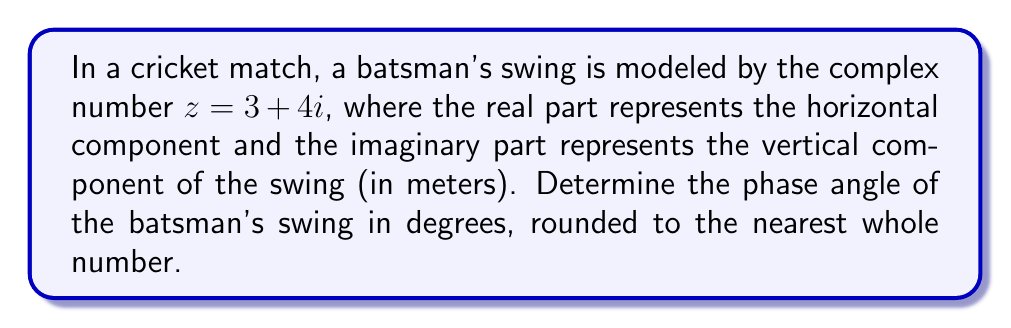Can you answer this question? To find the phase angle of the complex number $z = 3 + 4i$, we'll follow these steps:

1) The phase angle $\theta$ of a complex number $z = a + bi$ is given by:

   $\theta = \arctan(\frac{b}{a})$

2) In our case, $a = 3$ and $b = 4$. Substituting these values:

   $\theta = \arctan(\frac{4}{3})$

3) Using a calculator or mathematical software:

   $\theta \approx 0.9272952180016122$ radians

4) To convert radians to degrees, we multiply by $\frac{180}{\pi}$:

   $\theta_{degrees} = 0.9272952180016122 \times \frac{180}{\pi} \approx 53.13010235415598°$

5) Rounding to the nearest whole number:

   $\theta_{degrees} \approx 53°$

This angle represents the direction of the batsman's swing relative to the positive real axis (horizontal direction).
Answer: $53°$ 